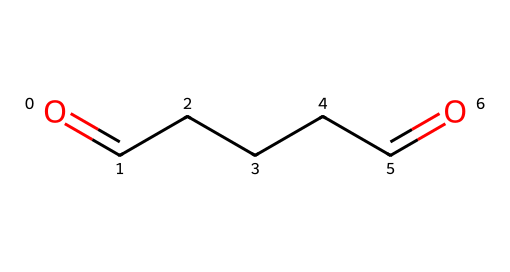What is the chemical name of the compound represented by the SMILES? The SMILES representation indicates the structure consists of two carbonyl groups (aldehyde) separated by a chain of three carbon atoms. This structure corresponds to glutaraldehyde.
Answer: glutaraldehyde How many carbon atoms are in this chemical? By analyzing the SMILES representation, we see there are five carbon atoms present in the linear structure.
Answer: five What is the total number of oxygen atoms in the structure? The SMILES shows two "O" characters, indicating that there are two oxygen atoms in the chemical structure.
Answer: two What type of functional groups are present in this chemical? The representation shows terminal carbonyl groups (C=O), characteristic of aldehydes, which means it has aldehyde functional groups.
Answer: aldehydes How many hydrogens would be associated with glutaraldehyde? To determine the number of hydrogen atoms, we consider each carbon in the structure contributing sufficient hydrogens to satisfy tetravalency, leading to 10 hydrogen atoms based on the chemical formula C5H10O2.
Answer: ten What does the presence of two aldehyde groups suggest about the reactivity of glutaraldehyde? The presence of two aldehyde groups indicates increased reactivity, particularly in condensation reactions and its utility as a powerful disinfectant and biocide.
Answer: increased reactivity Is glutaraldehyde more likely to act as a reducing agent or an oxidizing agent? In the context of its chemical behavior, aldehydes are more commonly known to act as reducing agents due to the ability of the carbonyl carbon to donate electrons.
Answer: reducing agent 